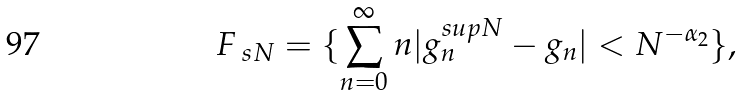Convert formula to latex. <formula><loc_0><loc_0><loc_500><loc_500>F _ { \ s N } = \{ \sum _ { n = 0 } ^ { \infty } n | g _ { n } ^ { s u p { N } } - g _ { n } | < N ^ { - \alpha _ { 2 } } \} ,</formula> 